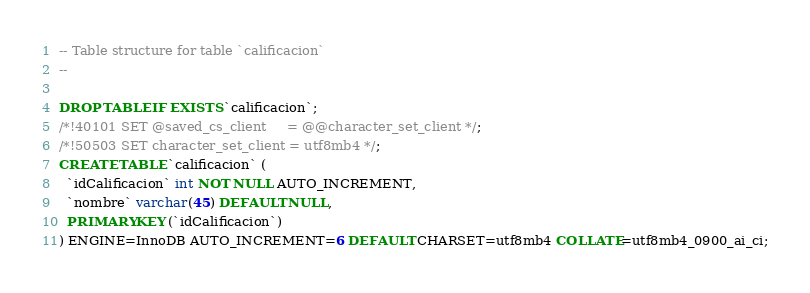Convert code to text. <code><loc_0><loc_0><loc_500><loc_500><_SQL_>-- Table structure for table `calificacion`
--

DROP TABLE IF EXISTS `calificacion`;
/*!40101 SET @saved_cs_client     = @@character_set_client */;
/*!50503 SET character_set_client = utf8mb4 */;
CREATE TABLE `calificacion` (
  `idCalificacion` int NOT NULL AUTO_INCREMENT,
  `nombre` varchar(45) DEFAULT NULL,
  PRIMARY KEY (`idCalificacion`)
) ENGINE=InnoDB AUTO_INCREMENT=6 DEFAULT CHARSET=utf8mb4 COLLATE=utf8mb4_0900_ai_ci;</code> 